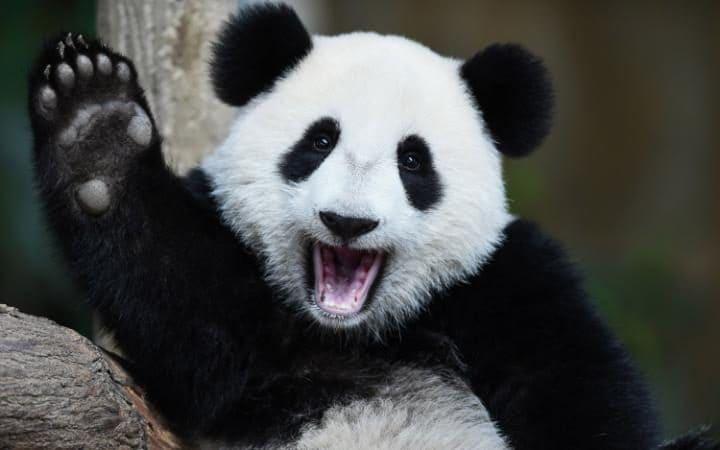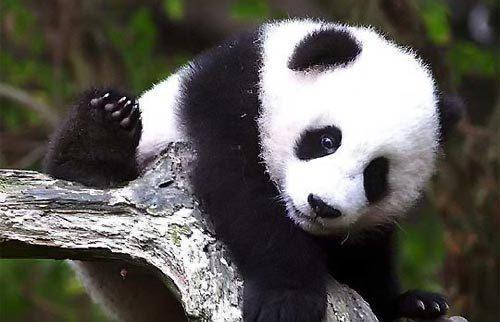The first image is the image on the left, the second image is the image on the right. Considering the images on both sides, is "In one image, a panda's mouth is open" valid? Answer yes or no. Yes. The first image is the image on the left, the second image is the image on the right. Examine the images to the left and right. Is the description "In one image, a panda is sitting on something that is not wood." accurate? Answer yes or no. No. 